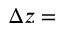<formula> <loc_0><loc_0><loc_500><loc_500>\Delta z =</formula> 